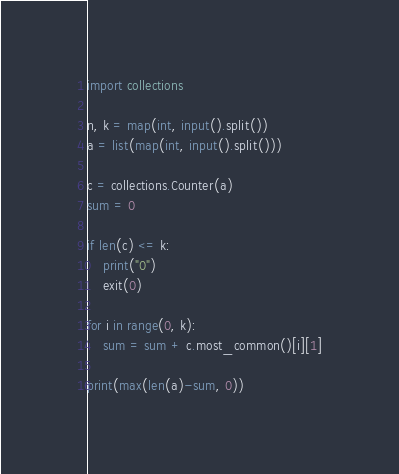<code> <loc_0><loc_0><loc_500><loc_500><_Python_>import collections

n, k = map(int, input().split())
a = list(map(int, input().split()))

c = collections.Counter(a)
sum = 0

if len(c) <= k:
    print("0")
    exit(0)

for i in range(0, k):
    sum = sum + c.most_common()[i][1]

print(max(len(a)-sum, 0))</code> 